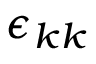Convert formula to latex. <formula><loc_0><loc_0><loc_500><loc_500>\epsilon _ { k k }</formula> 